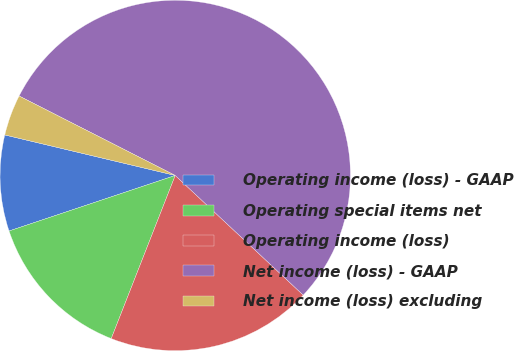Convert chart to OTSL. <chart><loc_0><loc_0><loc_500><loc_500><pie_chart><fcel>Operating income (loss) - GAAP<fcel>Operating special items net<fcel>Operating income (loss)<fcel>Net income (loss) - GAAP<fcel>Net income (loss) excluding<nl><fcel>8.85%<fcel>13.92%<fcel>18.99%<fcel>54.48%<fcel>3.78%<nl></chart> 